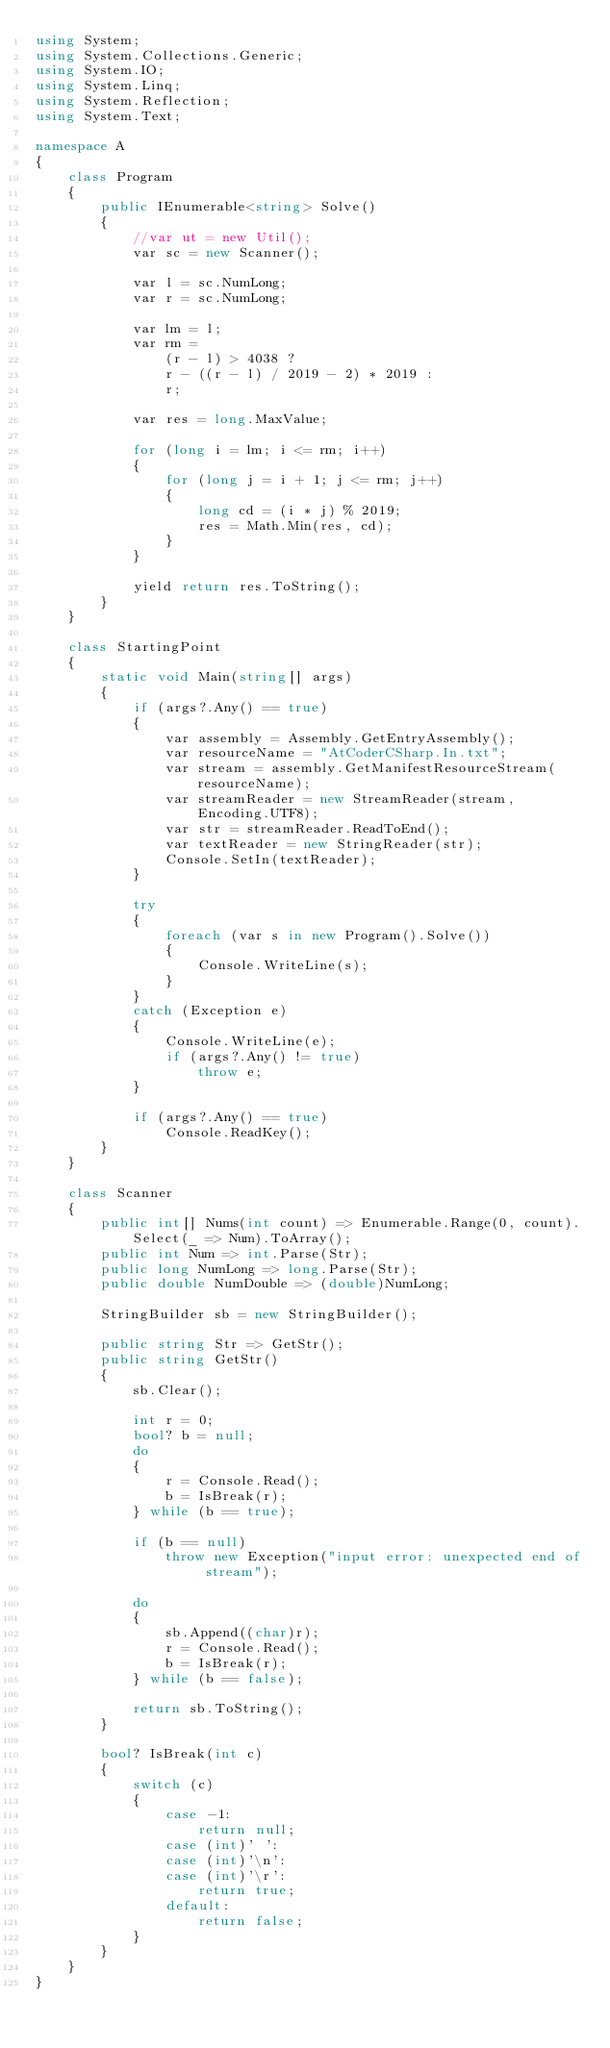<code> <loc_0><loc_0><loc_500><loc_500><_C#_>using System;
using System.Collections.Generic;
using System.IO;
using System.Linq;
using System.Reflection;
using System.Text;

namespace A
{
    class Program
    {
        public IEnumerable<string> Solve()
        {
            //var ut = new Util();
            var sc = new Scanner();

            var l = sc.NumLong;
            var r = sc.NumLong;

            var lm = l;
            var rm =
                (r - l) > 4038 ?
                r - ((r - l) / 2019 - 2) * 2019 :
                r;

            var res = long.MaxValue;

            for (long i = lm; i <= rm; i++)
            {
                for (long j = i + 1; j <= rm; j++)
                {
                    long cd = (i * j) % 2019;
                    res = Math.Min(res, cd);
                }
            }

            yield return res.ToString();
        }
    }

    class StartingPoint
    {
        static void Main(string[] args)
        {
            if (args?.Any() == true)
            {
                var assembly = Assembly.GetEntryAssembly();
                var resourceName = "AtCoderCSharp.In.txt";
                var stream = assembly.GetManifestResourceStream(resourceName);
                var streamReader = new StreamReader(stream, Encoding.UTF8);
                var str = streamReader.ReadToEnd();
                var textReader = new StringReader(str);
                Console.SetIn(textReader);
            }

            try
            {
                foreach (var s in new Program().Solve())
                {
                    Console.WriteLine(s);
                }
            }
            catch (Exception e)
            {
                Console.WriteLine(e);
                if (args?.Any() != true)
                    throw e;
            }

            if (args?.Any() == true)
                Console.ReadKey();
        }
    }

    class Scanner
    {
        public int[] Nums(int count) => Enumerable.Range(0, count).Select(_ => Num).ToArray();
        public int Num => int.Parse(Str);
        public long NumLong => long.Parse(Str);
        public double NumDouble => (double)NumLong;

        StringBuilder sb = new StringBuilder();

        public string Str => GetStr();
        public string GetStr()
        {
            sb.Clear();

            int r = 0;
            bool? b = null;
            do
            {
                r = Console.Read();
                b = IsBreak(r);
            } while (b == true);

            if (b == null)
                throw new Exception("input error: unexpected end of stream");

            do
            {
                sb.Append((char)r);
                r = Console.Read();
                b = IsBreak(r);
            } while (b == false);

            return sb.ToString();
        }

        bool? IsBreak(int c)
        {
            switch (c)
            {
                case -1:
                    return null;
                case (int)' ':
                case (int)'\n':
                case (int)'\r':
                    return true;
                default:
                    return false;
            }
        }
    }
}</code> 